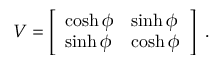Convert formula to latex. <formula><loc_0><loc_0><loc_500><loc_500>V = \left [ \begin{array} { l l } { \cosh \phi } & { \sinh \phi } \\ { \sinh \phi } & { \cosh \phi } \end{array} \right ] \ .</formula> 